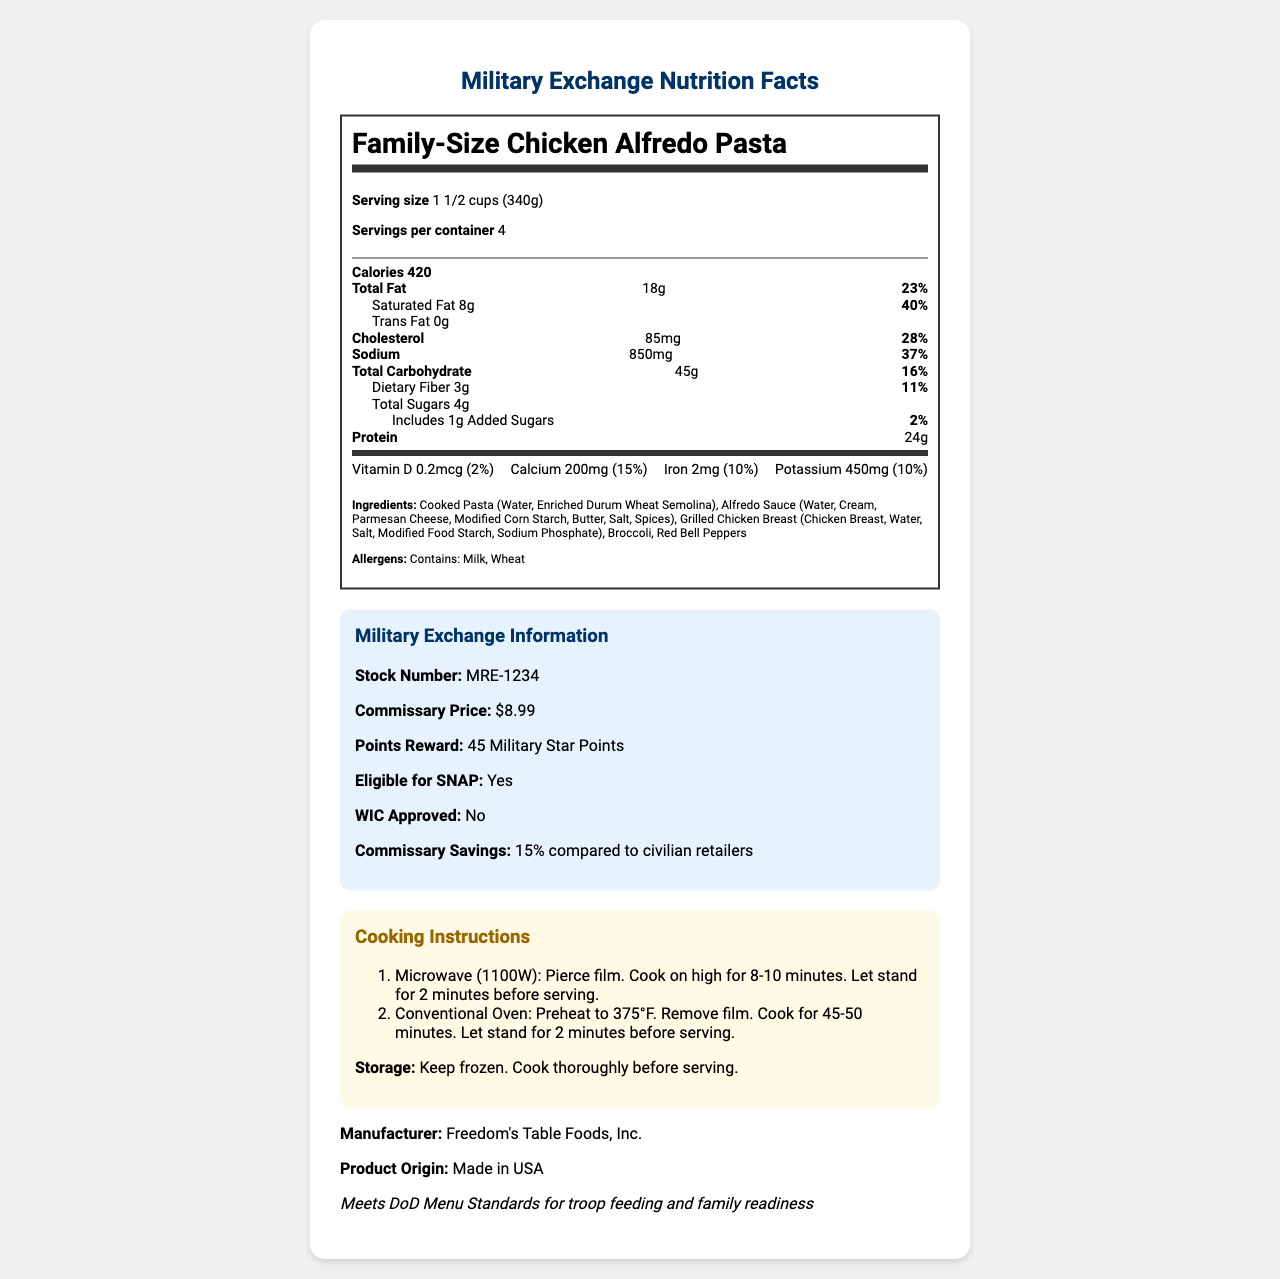what is the serving size? The serving size is listed as 1 1/2 cups (340g) in the serving info section of the document.
Answer: 1 1/2 cups (340g) How many servings are in the container? The number of servings per container is given as 4 in the serving info section.
Answer: 4 How many calories are in one serving of the Family-Size Chicken Alfredo Pasta? The calories for one serving are listed as 420 in the daily value section.
Answer: 420 calories What is the amount of saturated fat in one serving? The amount of saturated fat per serving is given as 8g in the daily value section.
Answer: 8g How much protein is in one serving? The protein amount in one serving is shown as 24g in the daily value section.
Answer: 24g What are the allergens listed for this product? The allergens are listed as Milk and Wheat in the ingredients section.
Answer: Milk, Wheat Which ingredient is not included in the Family-Size Chicken Alfredo Pasta? A. Broccoli B. Red Bell Peppers C. Mushrooms The ingredients list includes Broccoli and Red Bell Peppers but does not mention Mushrooms.
Answer: C. Mushrooms What cooking methods are provided for the Family-Size Chicken Alfredo Pasta? A. Microwave Only B. Conventional Oven Only C. Both Microwave and Conventional Oven The cooking instructions include both microwave and conventional oven methods.
Answer: C. Both Microwave and Conventional Oven Is this product eligible for WIC? The document states that the product is not WIC approved in the military family benefits section.
Answer: No Summarize the main idea of this document. The document covers a comprehensive overview, including details about serving size, nutritional content, ingredients, allergens, commissary price, reward points, storage instructions, cooking methods, and military-specific benefits and standards.
Answer: This document provides the nutrition facts, ingredients, allergens, military exchange information, cooking instructions, and military family benefits for the Family-Size Chicken Alfredo Pasta available through the military exchange system. Where is the manufacturer of this product located? The document mentions that the product's origin is the USA in the manufacturer section.
Answer: Made in USA How much calcium is provided per serving? The amount of calcium per serving is 200mg which is 15% of the daily value, as listed in the vitamins section.
Answer: 200mg (15% Daily Value) What is the DoD Menu Standards note mentioned in the document? The document states that the product meets DoD Menu Standards for troop feeding and family readiness.
Answer: Meets DoD Menu Standards for troop feeding and family readiness Compare the commissary price savings to civilian retailers. The commissary savings are listed as 15% compared to civilian retailers in the military family benefits section.
Answer: 15% savings What is the stock number for this product? A. MRE-6789 B. MRE-1234 C. MRE-4321 D. MRE-9876 The stock number MRE-1234 is listed under the military exchange information.
Answer: B. MRE-1234 How much trans fat does this product contain? The trans fat content is listed as 0g in the daily value section.
Answer: 0g Does the product meet DoD Menu Standards for feeding and readiness? The military nutrition note confirms that the product meets DoD Menu Standards for troop feeding and family readiness.
Answer: Yes What are the steps for conventional oven cooking? The steps for conventional oven cooking are under the cooking instructions section.
Answer: Preheat to 375°F. Remove film. Cook for 45-50 minutes. Let stand for 2 minutes before serving. What is the shelf-life of this product when stored properly? The document provides storage instructions but does not mention the shelf-life of the product.
Answer: Not enough information What percentage of the daily value of sodium does one serving account for? The sodium content per serving is 850mg, which is 37% of the daily value as stated in the daily value section.
Answer: 37% 